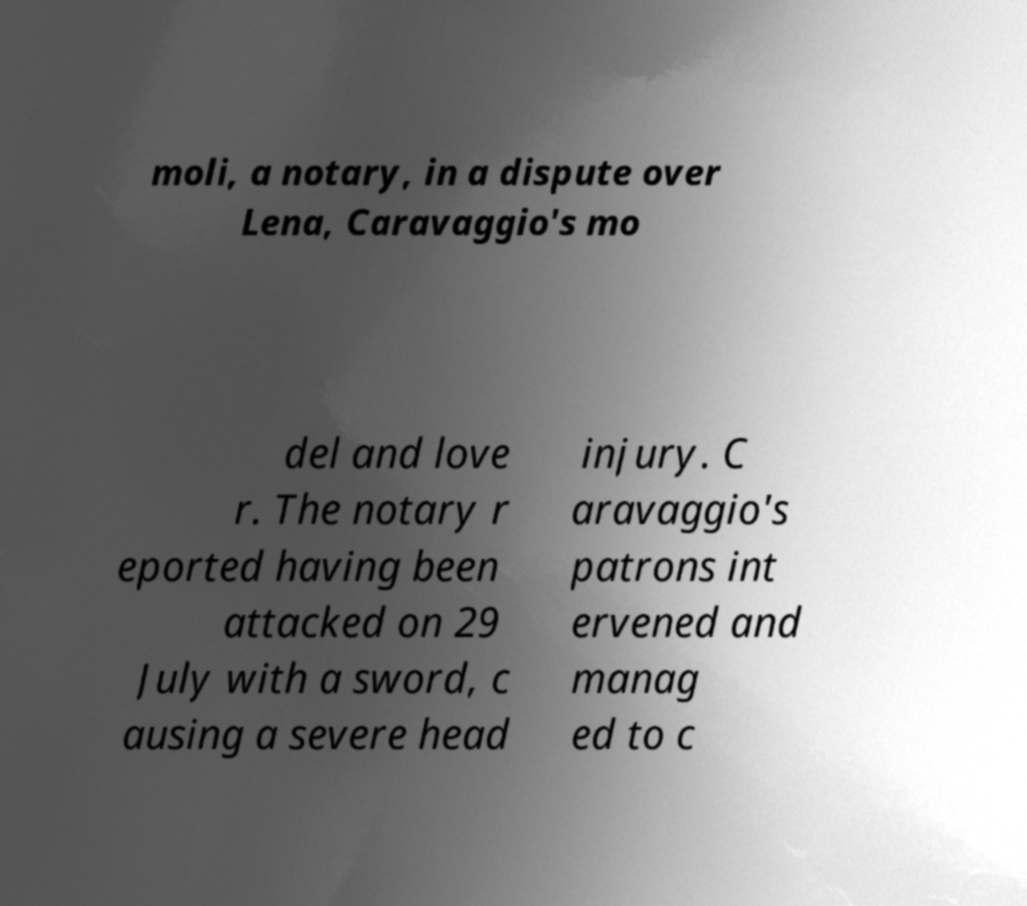Please identify and transcribe the text found in this image. moli, a notary, in a dispute over Lena, Caravaggio's mo del and love r. The notary r eported having been attacked on 29 July with a sword, c ausing a severe head injury. C aravaggio's patrons int ervened and manag ed to c 